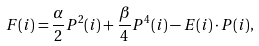<formula> <loc_0><loc_0><loc_500><loc_500>F ( i ) = \frac { \alpha } { 2 } P ^ { 2 } ( i ) + \frac { \beta } { 4 } P ^ { 4 } ( i ) - { E } ( i ) \cdot { P } ( i ) ,</formula> 